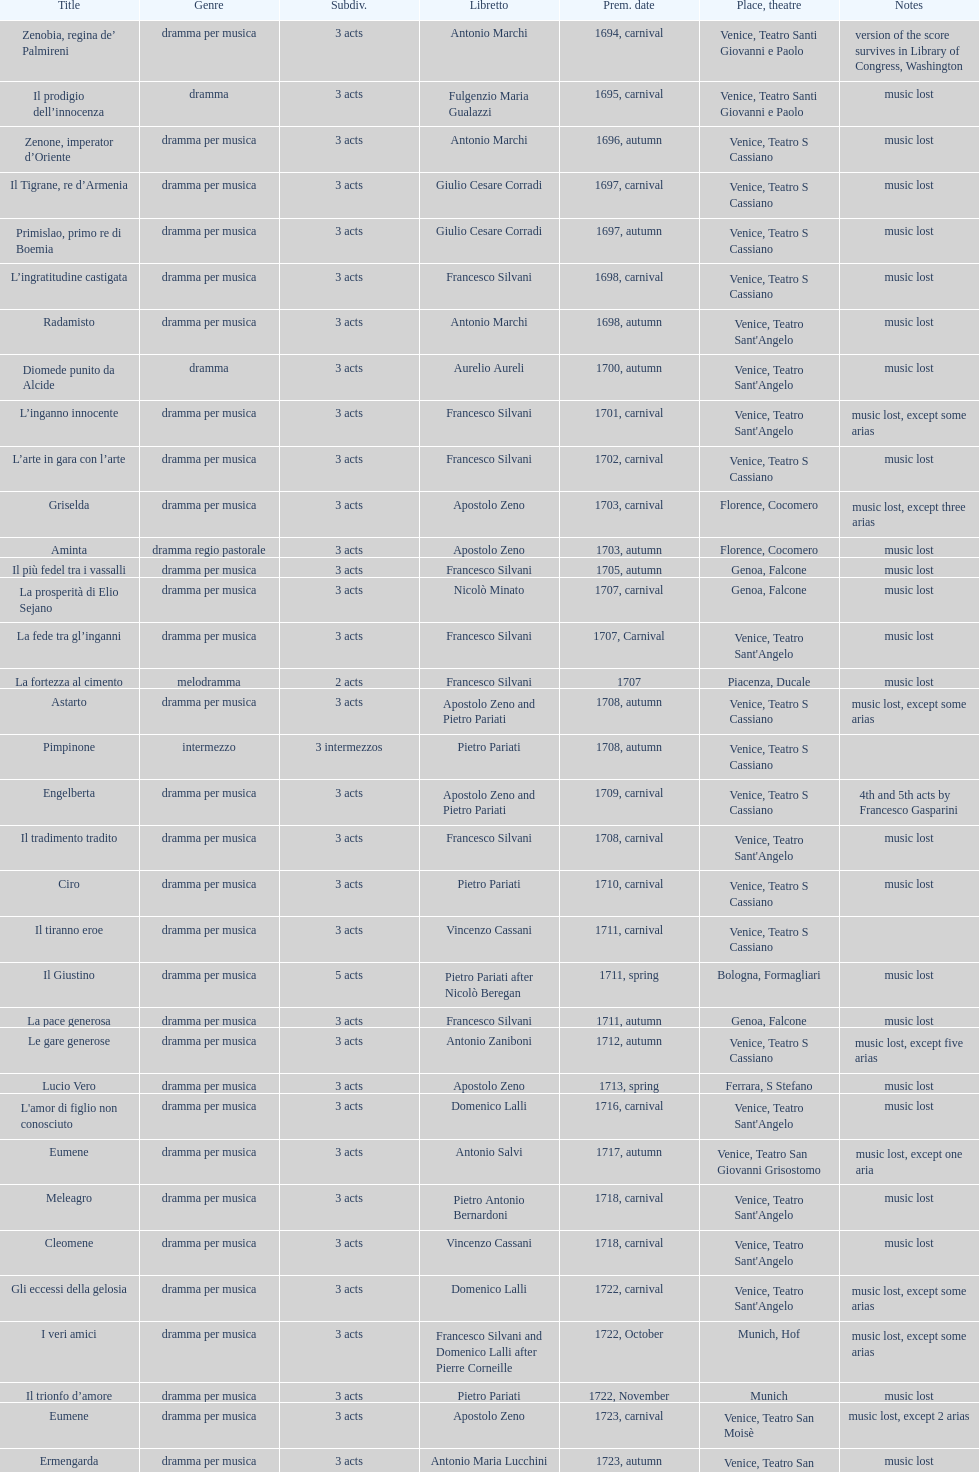What is next after ardelinda? Candalide. 